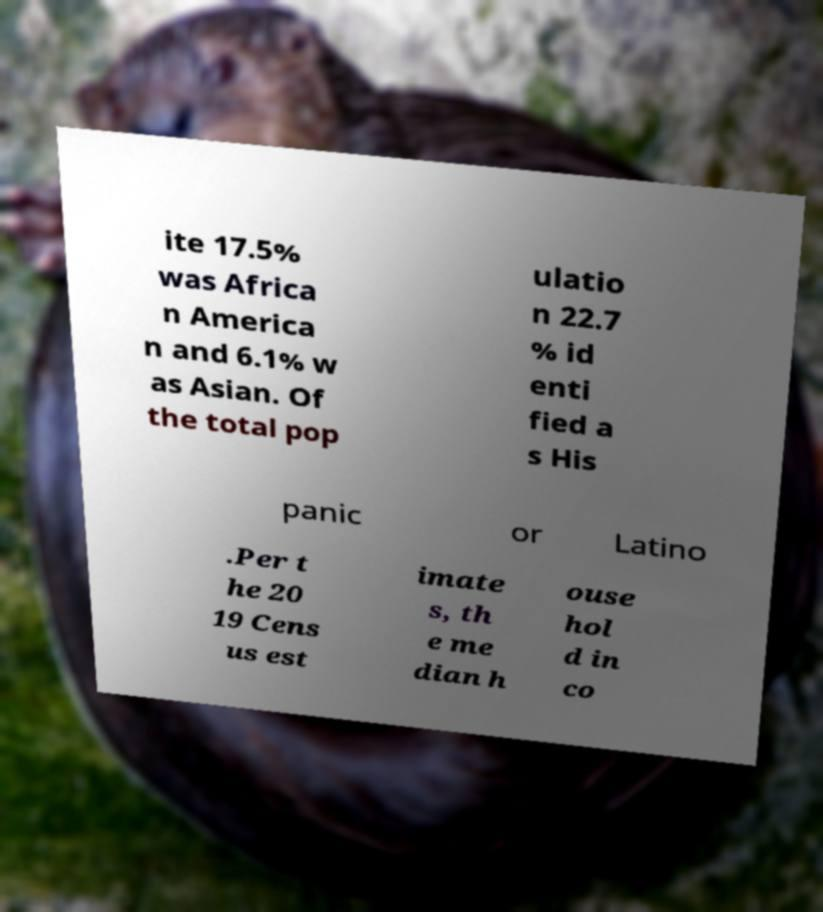Please read and relay the text visible in this image. What does it say? ite 17.5% was Africa n America n and 6.1% w as Asian. Of the total pop ulatio n 22.7 % id enti fied a s His panic or Latino .Per t he 20 19 Cens us est imate s, th e me dian h ouse hol d in co 